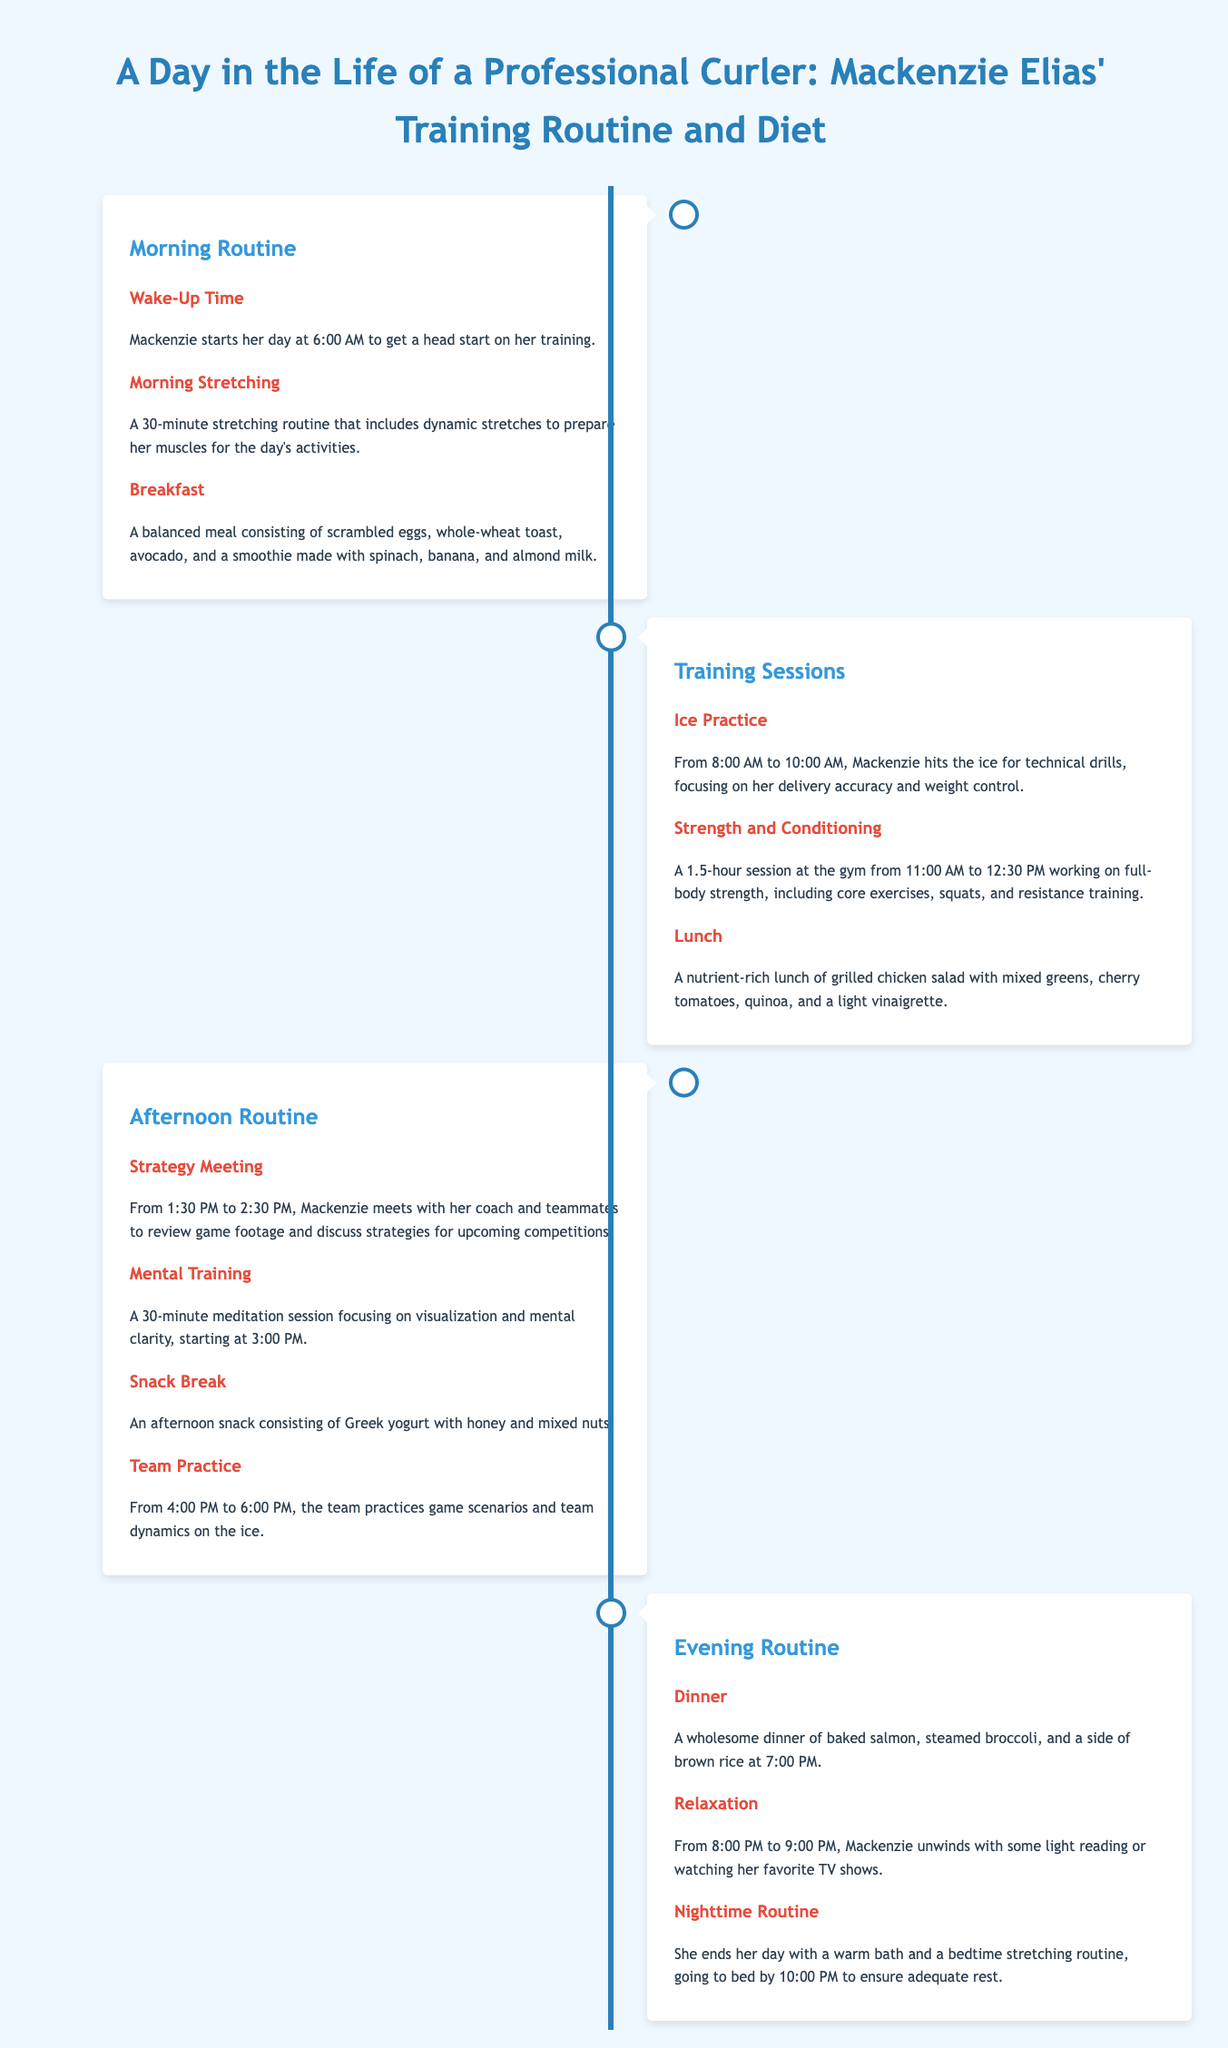what time does Mackenzie wake up? The document states that Mackenzie starts her day at 6:00 AM.
Answer: 6:00 AM how long does Mackenzie's morning stretching routine last? The morning stretching routine is mentioned to last for 30 minutes.
Answer: 30 minutes what type of meal does Mackenzie have for lunch? The lunch is described as a nutrient-rich lunch of grilled chicken salad with specific ingredients.
Answer: grilled chicken salad how long is the strength and conditioning session? The document indicates that the strength and conditioning session lasts for 1.5 hours.
Answer: 1.5 hours what activity does Mackenzie engage in from 1:30 PM to 2:30 PM? The document mentions that she meets with her coach and teammates for a strategy meeting.
Answer: strategy meeting what does Mackenzie do for her afternoon snack? The document lists her afternoon snack as Greek yogurt with honey and mixed nuts.
Answer: Greek yogurt with honey and mixed nuts when does Mackenzie have dinner? The dinner time is specified as 7:00 PM in the document.
Answer: 7:00 PM what two activities does Mackenzie do to relax in the evening? The document states she unwinds with light reading or watching her favorite TV shows.
Answer: light reading or watching TV what does Mackenzie do to prepare for bedtime? The document mentions that she ends her day with a warm bath and bedtime stretching routine.
Answer: warm bath and bedtime stretching routine 